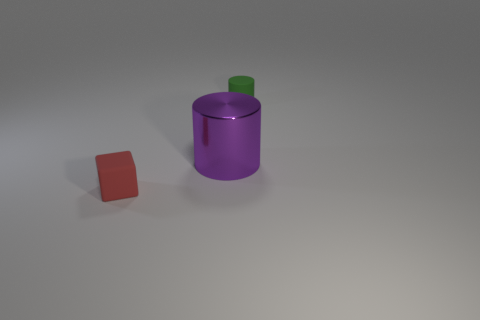Add 1 tiny green spheres. How many objects exist? 4 Subtract all cylinders. How many objects are left? 1 Subtract all matte objects. Subtract all tiny red metal cubes. How many objects are left? 1 Add 2 big purple things. How many big purple things are left? 3 Add 1 small blue things. How many small blue things exist? 1 Subtract 0 cyan cylinders. How many objects are left? 3 